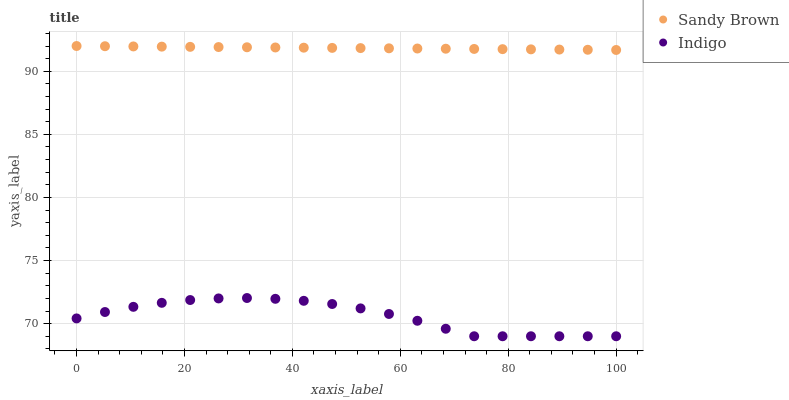Does Indigo have the minimum area under the curve?
Answer yes or no. Yes. Does Sandy Brown have the maximum area under the curve?
Answer yes or no. Yes. Does Sandy Brown have the minimum area under the curve?
Answer yes or no. No. Is Sandy Brown the smoothest?
Answer yes or no. Yes. Is Indigo the roughest?
Answer yes or no. Yes. Is Sandy Brown the roughest?
Answer yes or no. No. Does Indigo have the lowest value?
Answer yes or no. Yes. Does Sandy Brown have the lowest value?
Answer yes or no. No. Does Sandy Brown have the highest value?
Answer yes or no. Yes. Is Indigo less than Sandy Brown?
Answer yes or no. Yes. Is Sandy Brown greater than Indigo?
Answer yes or no. Yes. Does Indigo intersect Sandy Brown?
Answer yes or no. No. 